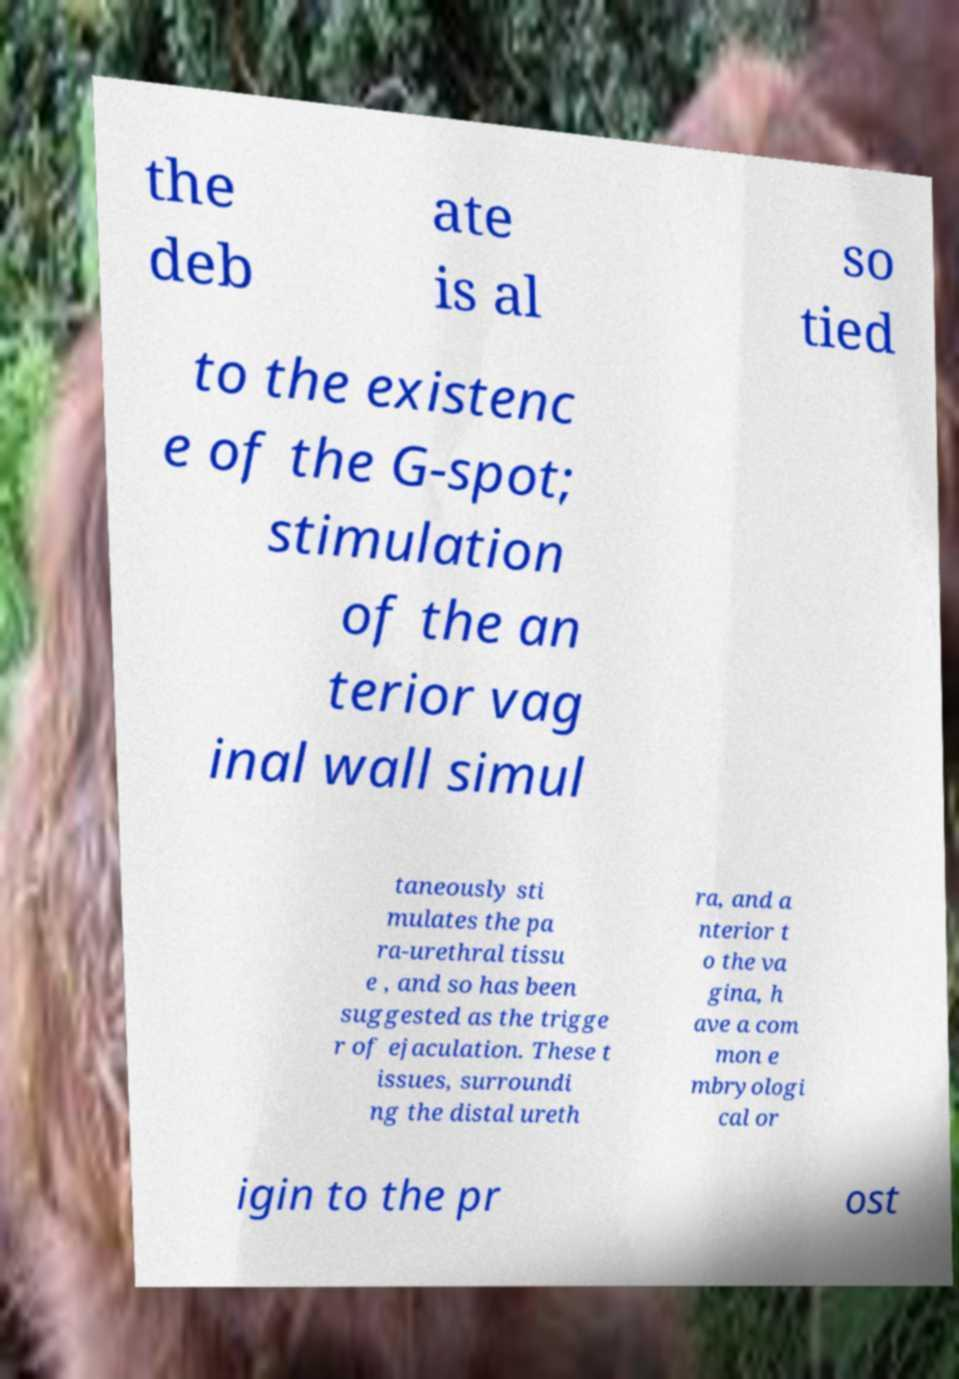Please read and relay the text visible in this image. What does it say? the deb ate is al so tied to the existenc e of the G-spot; stimulation of the an terior vag inal wall simul taneously sti mulates the pa ra-urethral tissu e , and so has been suggested as the trigge r of ejaculation. These t issues, surroundi ng the distal ureth ra, and a nterior t o the va gina, h ave a com mon e mbryologi cal or igin to the pr ost 